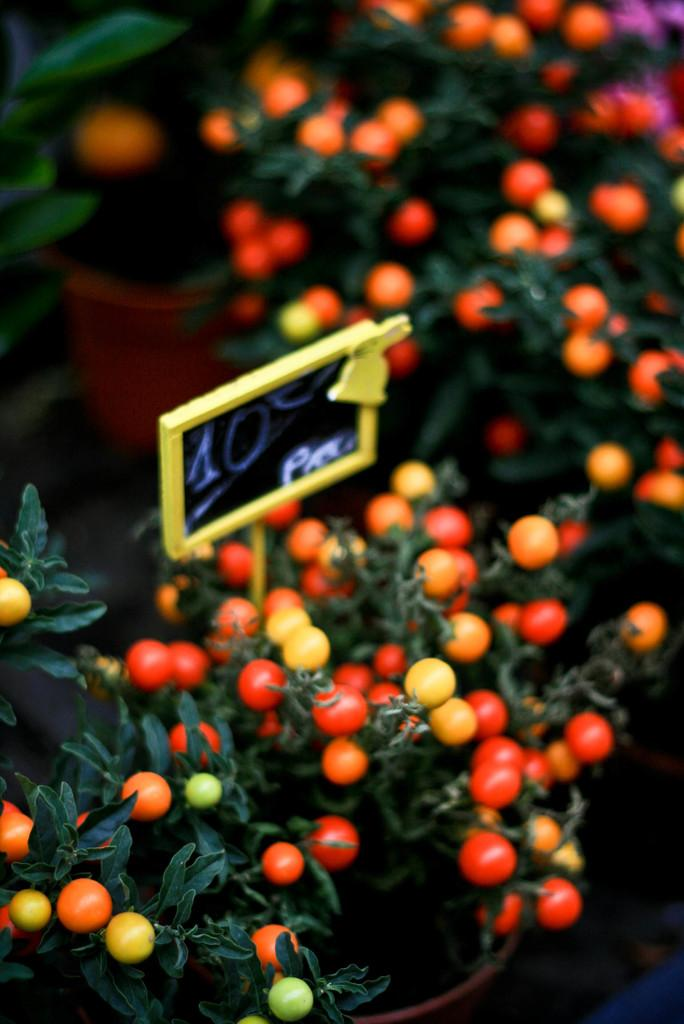What is the main subject of the image? The main subject of the image is many plants. How are the plants arranged or organized in the image? The plants are in plant pots in the image. What can be seen on the plants in the image? There are fruits on the plants in the image. Is there any other object or structure visible in the image? Yes, there is a board in the image. How many mice can be seen running around the yard in the image? There are no mice or yard present in the image; it features many plants in plant pots with fruits and a board. 